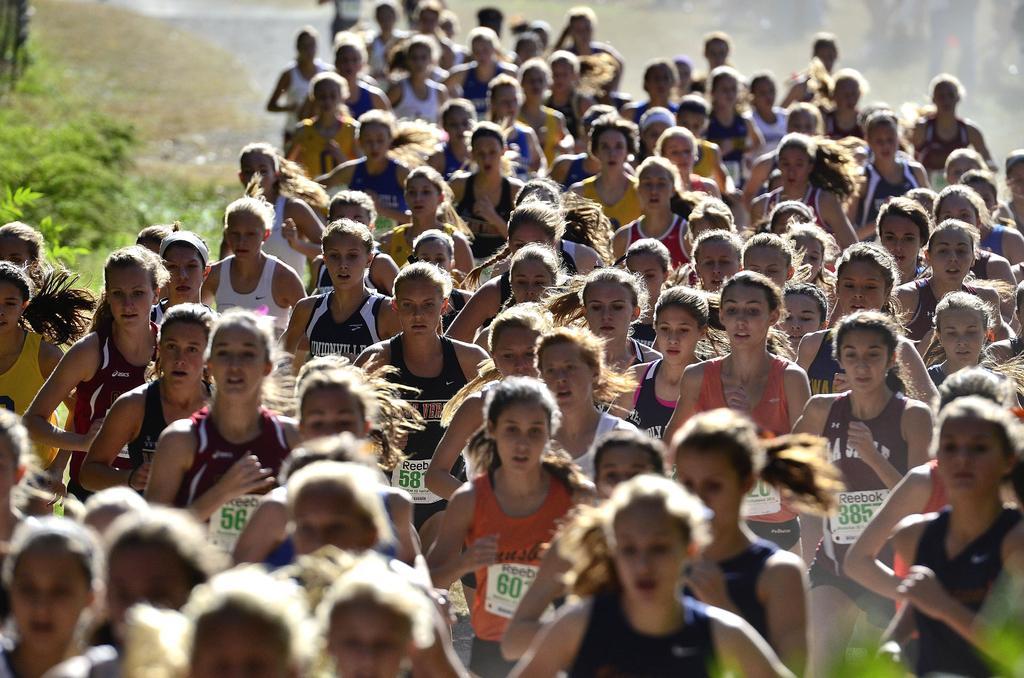Could you give a brief overview of what you see in this image? In the center of the image we can see a group of people are running and they are in different color t shirts. And we can see the banners on their t shirts. In the background we can see plants, grass, road etc. 